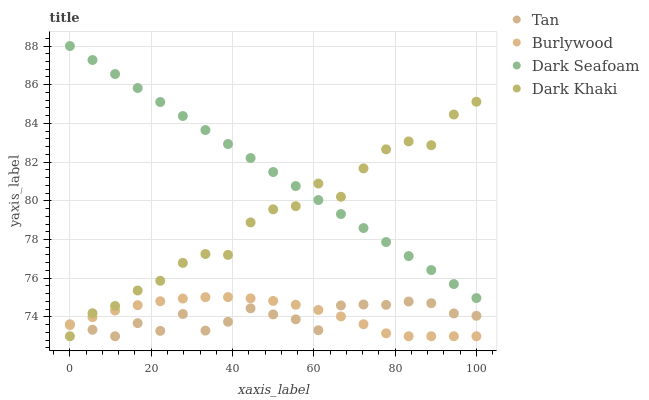Does Tan have the minimum area under the curve?
Answer yes or no. Yes. Does Dark Seafoam have the maximum area under the curve?
Answer yes or no. Yes. Does Dark Khaki have the minimum area under the curve?
Answer yes or no. No. Does Dark Khaki have the maximum area under the curve?
Answer yes or no. No. Is Dark Seafoam the smoothest?
Answer yes or no. Yes. Is Dark Khaki the roughest?
Answer yes or no. Yes. Is Tan the smoothest?
Answer yes or no. No. Is Tan the roughest?
Answer yes or no. No. Does Burlywood have the lowest value?
Answer yes or no. Yes. Does Dark Seafoam have the lowest value?
Answer yes or no. No. Does Dark Seafoam have the highest value?
Answer yes or no. Yes. Does Dark Khaki have the highest value?
Answer yes or no. No. Is Tan less than Dark Seafoam?
Answer yes or no. Yes. Is Dark Seafoam greater than Burlywood?
Answer yes or no. Yes. Does Dark Khaki intersect Dark Seafoam?
Answer yes or no. Yes. Is Dark Khaki less than Dark Seafoam?
Answer yes or no. No. Is Dark Khaki greater than Dark Seafoam?
Answer yes or no. No. Does Tan intersect Dark Seafoam?
Answer yes or no. No. 